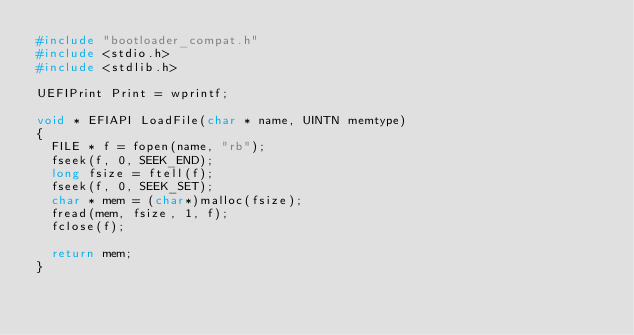Convert code to text. <code><loc_0><loc_0><loc_500><loc_500><_C++_>#include "bootloader_compat.h"
#include <stdio.h>
#include <stdlib.h>

UEFIPrint Print = wprintf;

void * EFIAPI LoadFile(char * name, UINTN memtype)
{
  FILE * f = fopen(name, "rb");
  fseek(f, 0, SEEK_END);
  long fsize = ftell(f);
  fseek(f, 0, SEEK_SET);
  char * mem = (char*)malloc(fsize);
  fread(mem, fsize, 1, f);
  fclose(f);

  return mem;
}
</code> 